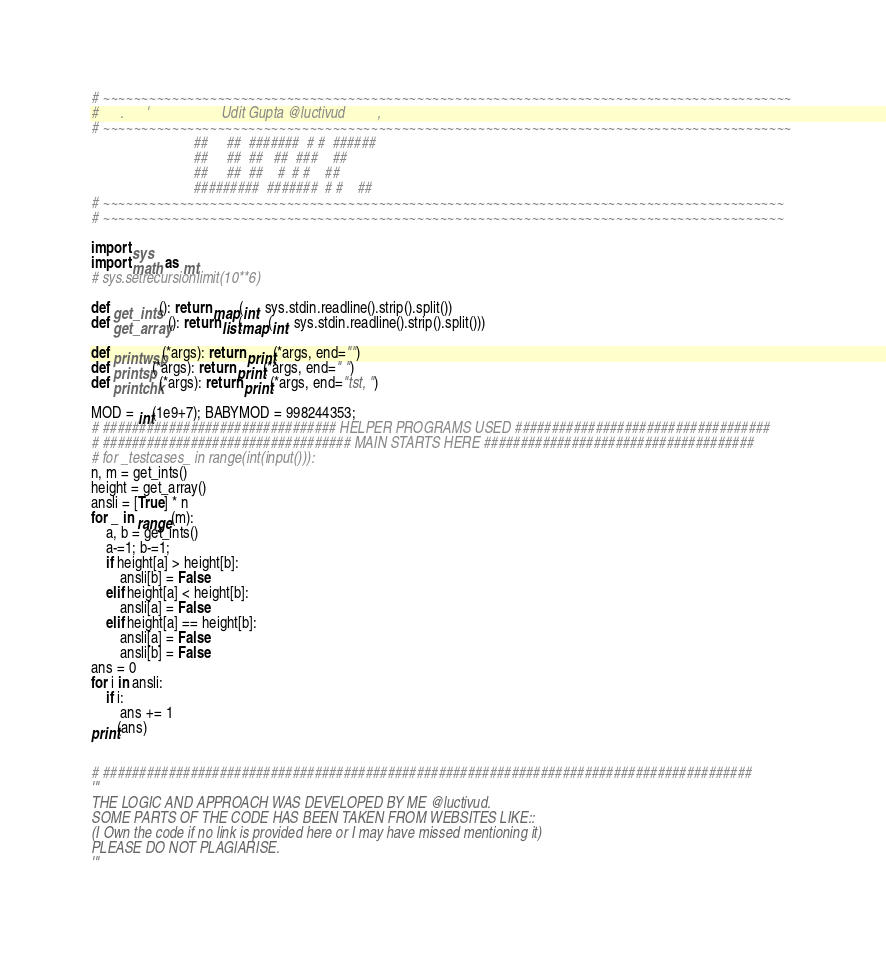Convert code to text. <code><loc_0><loc_0><loc_500><loc_500><_Python_># ~~~~~~~~~~~~~~~~~~~~~~~~~~~~~~~~~~~~~~~~~~~~~~~~~~~~~~~~~~~~~~~~~~~~~~~~~~~~~~~~~~~~~~~~~~ 
#      .      '                    Udit Gupta @luctivud         ,              
# ~~~~~~~~~~~~~~~~~~~~~~~~~~~~~~~~~~~~~~~~~~~~~~~~~~~~~~~~~~~~~~~~~~~~~~~~~~~~~~~~~~~~~~~~~~
                            ##     ##  #######  # #  ######
                            ##     ##  ##   ##  ###    ##
                            ##     ##  ##    #  # #    ##
                            #########  #######  # #    ##
# ~~~~~~~~~~~~~~~~~~~~~~~~~~~~~~~~~~~~~~~~~~~~~~~~~~~~~~~~~~~~~~~~~~~~~~~~~~~~~~~~~~~~~~~~~
# ~~~~~~~~~~~~~~~~~~~~~~~~~~~~~~~~~~~~~~~~~~~~~~~~~~~~~~~~~~~~~~~~~~~~~~~~~~~~~~~~~~~~~~~~~

import sys
import math as mt
# sys.setrecursionlimit(10**6)

def get_ints(): return map(int, sys.stdin.readline().strip().split())
def get_array(): return list(map(int, sys.stdin.readline().strip().split()))

def printwsp(*args): return print(*args, end="")
def printsp(*args): return print(*args, end=" ")
def printchk(*args): return print(*args, end="tst, ")

MOD = int(1e9+7); BABYMOD = 998244353;
# ################################ HELPER PROGRAMS USED ###################################
# ################################## MAIN STARTS HERE #####################################
# for _testcases_ in range(int(input())):
n, m = get_ints()
height = get_array()
ansli = [True] * n
for _ in range(m):
    a, b = get_ints()
    a-=1; b-=1;
    if height[a] > height[b]:
        ansli[b] = False
    elif height[a] < height[b]:
        ansli[a] = False
    elif height[a] == height[b]:
        ansli[a] = False
        ansli[b] = False
ans = 0
for i in ansli:
    if i:
        ans += 1
print(ans)


# #########################################################################################
'''
THE LOGIC AND APPROACH WAS DEVELOPED BY ME @luctivud.
SOME PARTS OF THE CODE HAS BEEN TAKEN FROM WEBSITES LIKE::
(I Own the code if no link is provided here or I may have missed mentioning it)
PLEASE DO NOT PLAGIARISE.
'''</code> 